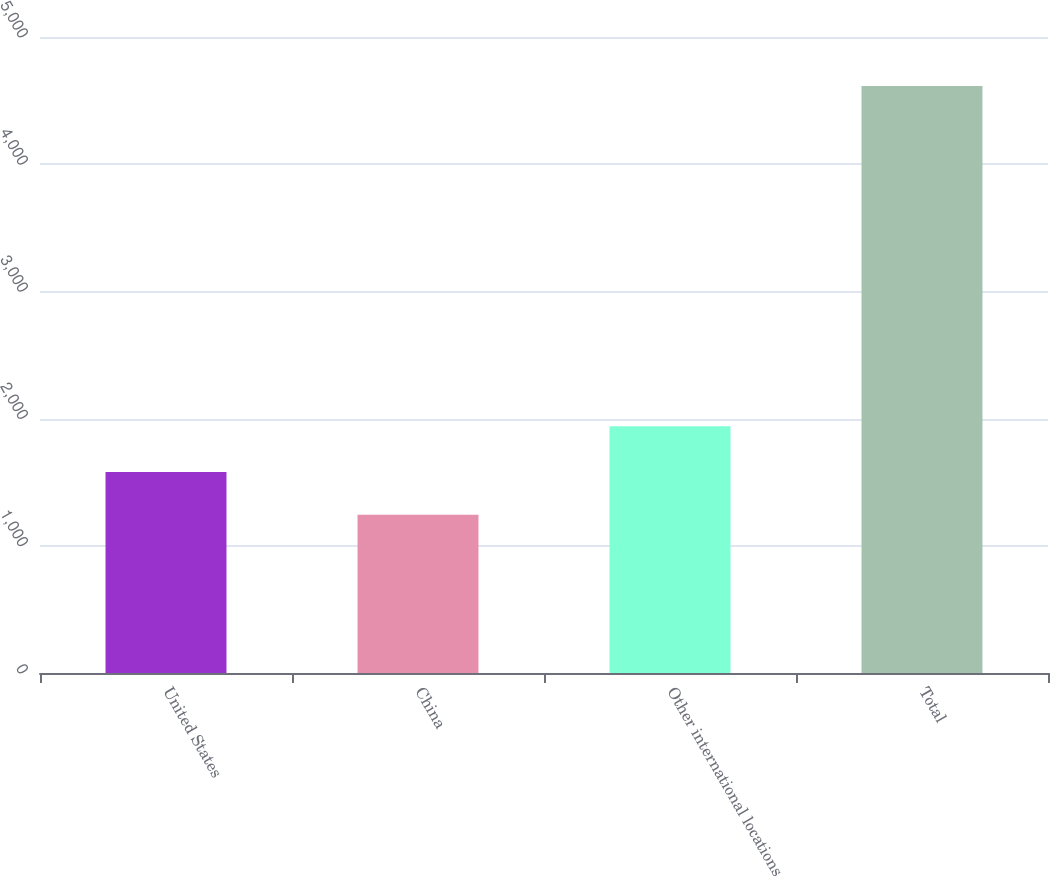Convert chart. <chart><loc_0><loc_0><loc_500><loc_500><bar_chart><fcel>United States<fcel>China<fcel>Other international locations<fcel>Total<nl><fcel>1580.8<fcel>1243.7<fcel>1940.5<fcel>4614.7<nl></chart> 